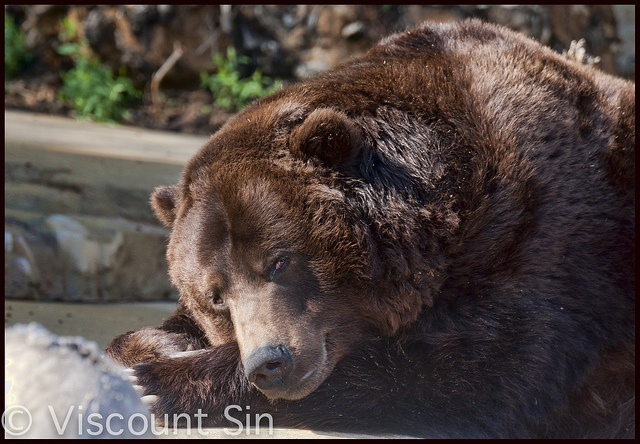Describe the objects in this image and their specific colors. I can see a bear in black, gray, and maroon tones in this image. 